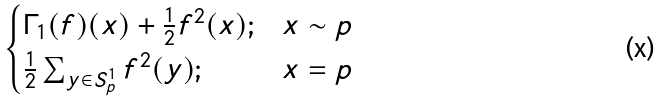<formula> <loc_0><loc_0><loc_500><loc_500>\begin{cases} \Gamma _ { 1 } ( f ) ( x ) + \frac { 1 } { 2 } f ^ { 2 } ( x ) ; & x \sim p \\ \frac { 1 } { 2 } \sum _ { y \in S ^ { 1 } _ { p } } f ^ { 2 } ( y ) ; & x = p \\ \end{cases}</formula> 